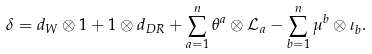<formula> <loc_0><loc_0><loc_500><loc_500>\delta = d _ { W } \otimes 1 + 1 \otimes d _ { D R } + \sum _ { a = 1 } ^ { n } \theta ^ { a } \otimes { \mathcal { L } } _ { a } - \sum _ { b = 1 } ^ { n } \mu ^ { b } \otimes \iota _ { b } .</formula> 